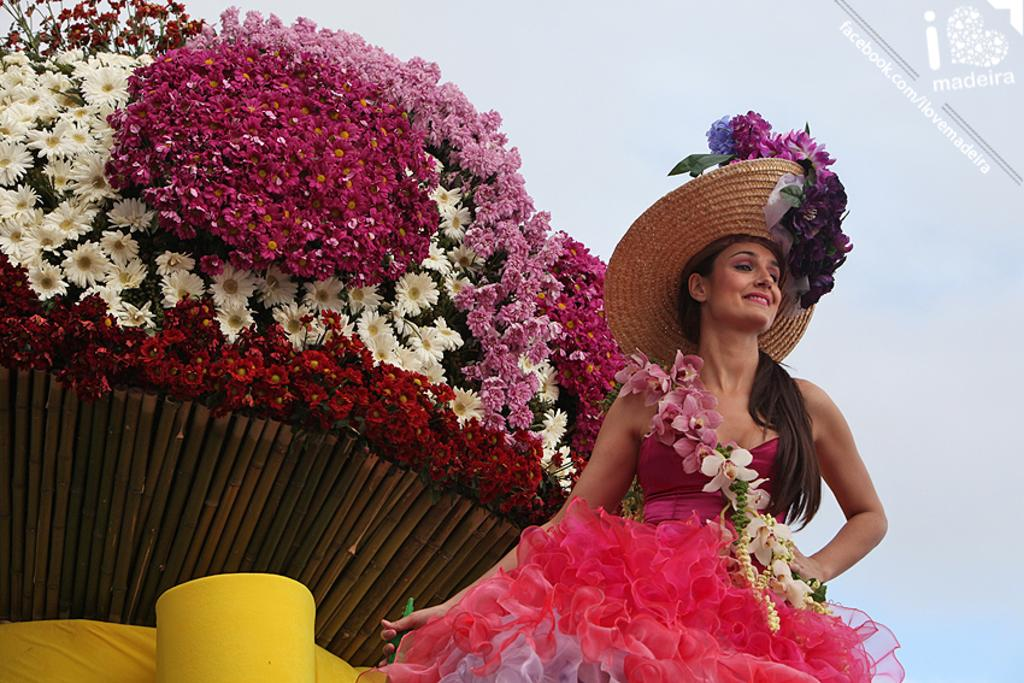Who is present in the image? There is a woman in the image. What can be seen in the background of the image? There are flowers in the background of the image. What type of ticket does the woman have in her hand in the image? There is no ticket present in the image; the woman is not holding anything. 